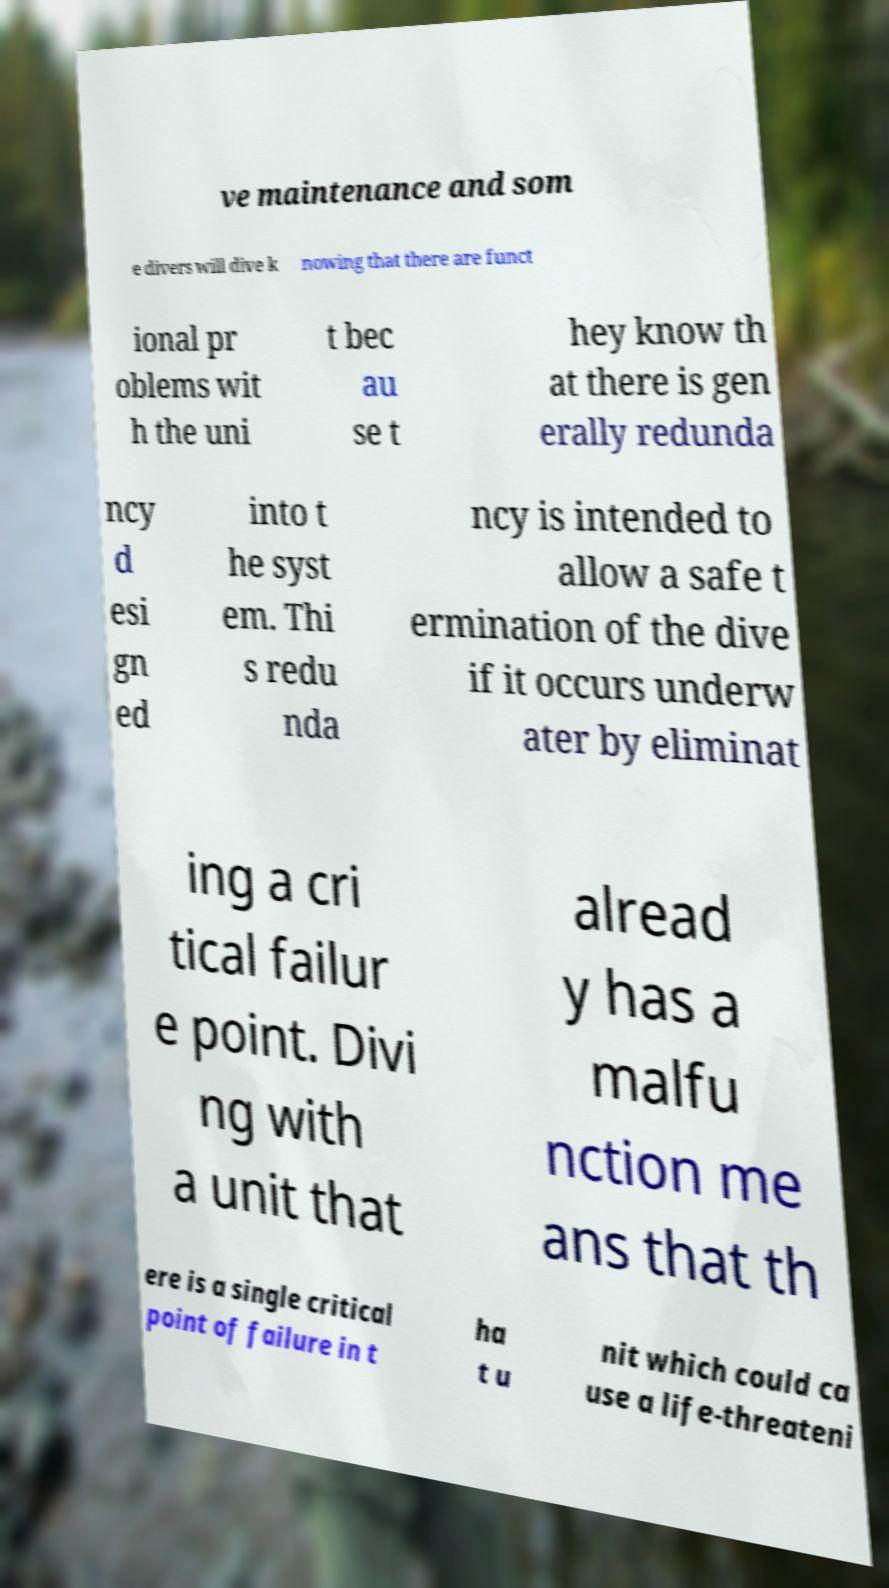Can you read and provide the text displayed in the image?This photo seems to have some interesting text. Can you extract and type it out for me? ve maintenance and som e divers will dive k nowing that there are funct ional pr oblems wit h the uni t bec au se t hey know th at there is gen erally redunda ncy d esi gn ed into t he syst em. Thi s redu nda ncy is intended to allow a safe t ermination of the dive if it occurs underw ater by eliminat ing a cri tical failur e point. Divi ng with a unit that alread y has a malfu nction me ans that th ere is a single critical point of failure in t ha t u nit which could ca use a life-threateni 